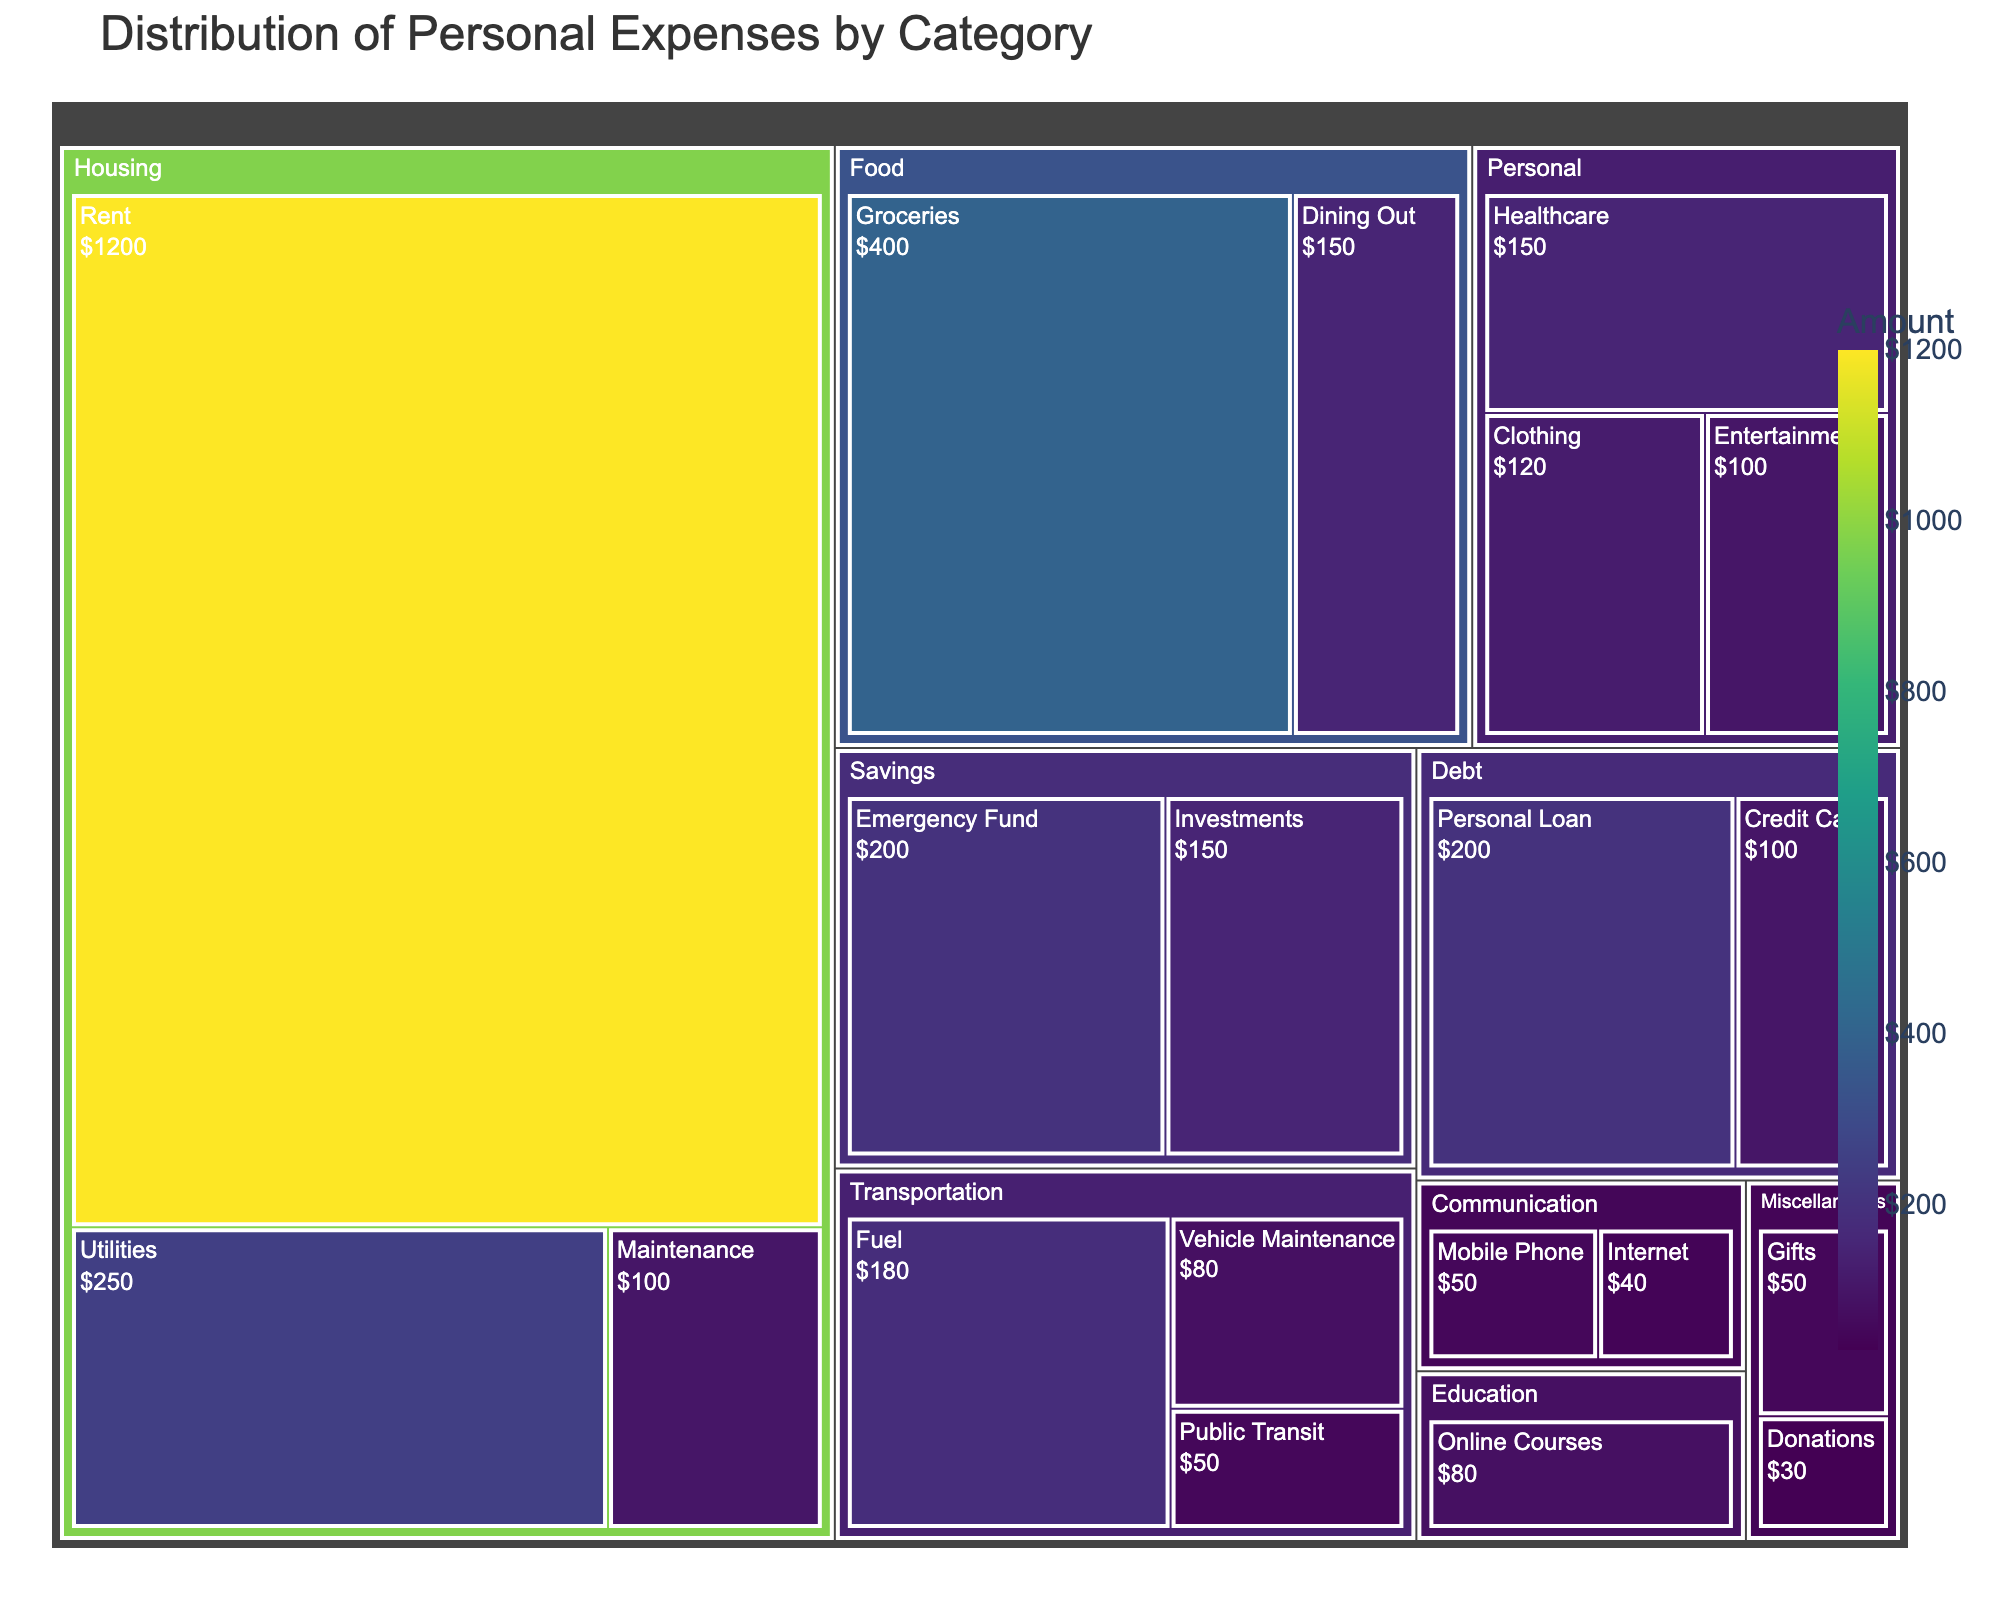what is the title of the treemap? The title is highlighted at the top of the treemap, often larger and bolder than other text.
Answer: Distribution of Personal Expenses by Category Which subcategory under Housing has the highest expense? Look under the Housing category and identify the subcategory with the largest block.
Answer: Rent What is the total amount spent on Transportation? Sum the values of all subcategories under Transportation: Fuel ($180), Public Transit ($50), and Vehicle Maintenance ($80). Total is $180 + $50 + $80 = $310.
Answer: $310 How do expenses on Dining Out compare to expenses on Groceries? Check the sizes or values of the Dining Out and Groceries subcategories under Food. Dining Out is $150, and Groceries is $400. Since $400 > $150, Groceries expenses are greater than Dining Out.
Answer: Groceries expenses are greater Which category has the smallest total expense? Identify the category with the smallest total sum of its subcategories. The Miscellaneous category has combined expenses: Gifts ($50) + Donations ($30) = $80, which is the smallest total.
Answer: Miscellaneous What's the monetary difference between expenses on Healthcare and Clothing? Healthcare expenses are $150 and Clothing expenses are $120. Subtract the smaller value from the larger: $150 - $120 = $30.
Answer: $30 What is the combined expense of all subcategories under Debt? Sum the values of all subcategories under Debt: Credit Card ($100) and Personal Loan ($200). Total is $100 + $200 = $300.
Answer: $300 Is the Emergency Fund expense higher or lower than the Internet expense? Compare the values of Emergency Fund ($200) and Internet ($40). Since $200 > $40, Emergency Fund expense is higher.
Answer: Higher Which category has more expense, Personal or Communication? Compare the total expenses of the categories. Personal has Clothing ($120) + Healthcare ($150) + Entertainment ($100) = $370, and Communication has Mobile Phone ($50) + Internet ($40) = $90. Personal has more expenses.
Answer: Personal What’s the percentage of Rent expense in the total Housing category expenses? Calculate the percentage of Rent in the Housing total. Rent ($1200) out of total Housing ($1200 + $250 + $100) = $1550. So, (1200 / 1550) * 100% = 77.42%.
Answer: 77.42% 